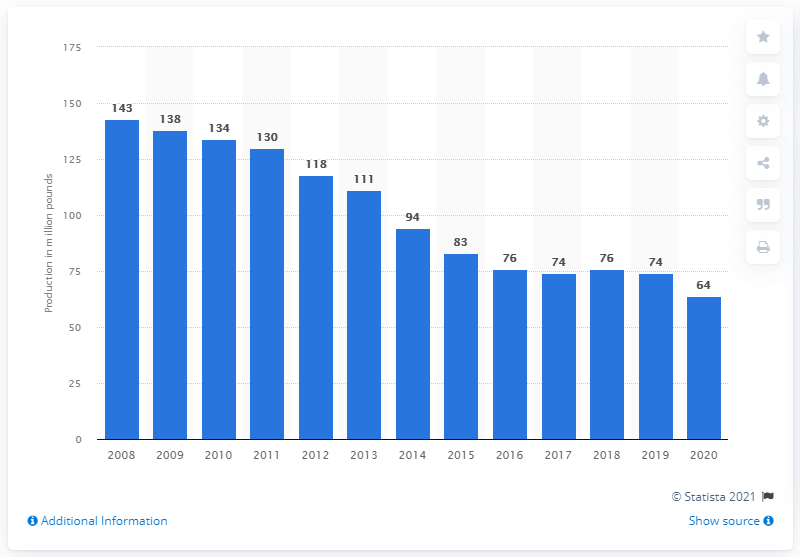Mention a couple of crucial points in this snapshot. In 2020, the commercial production of veal in the United States was approximately 64 million pounds. 